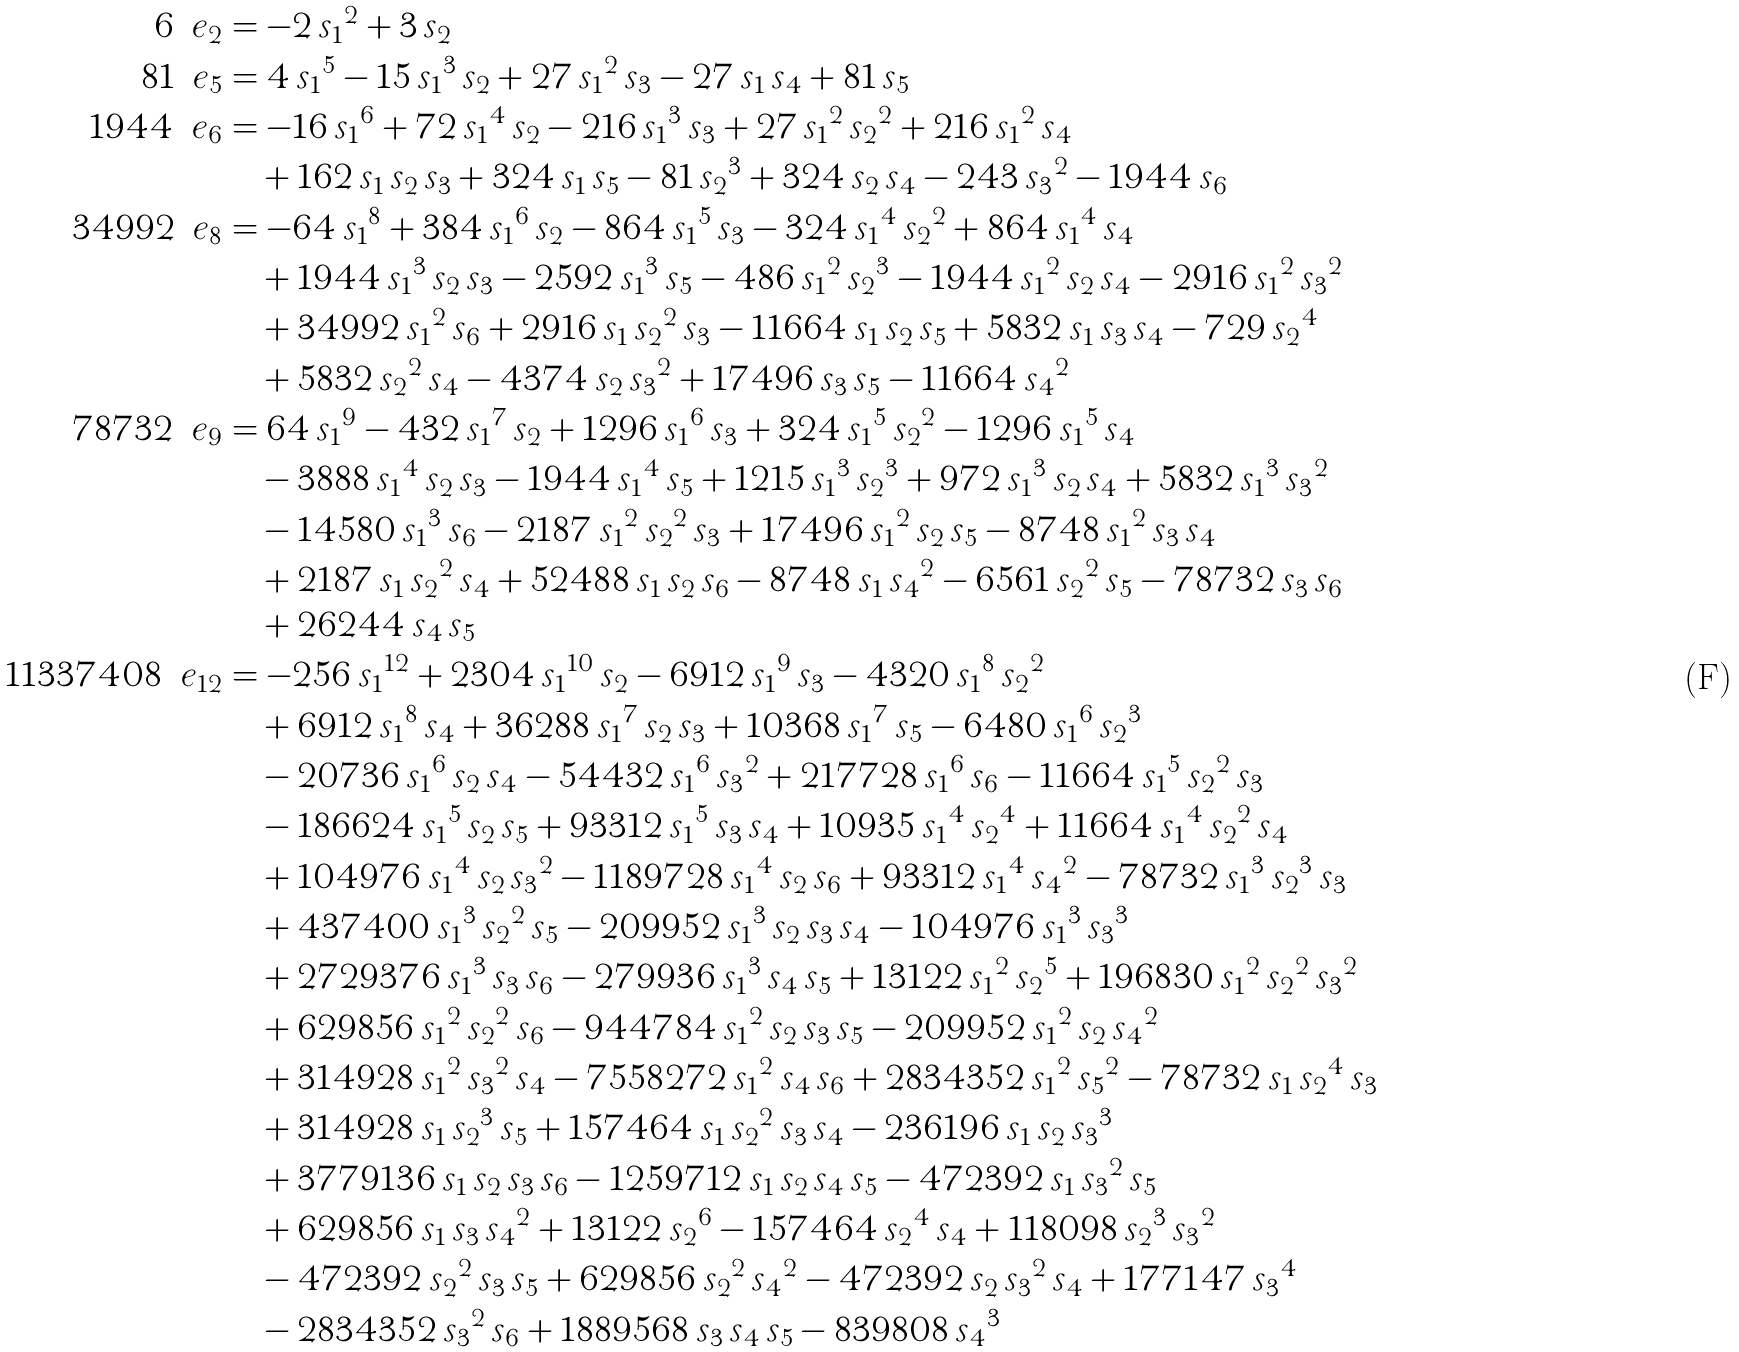Convert formula to latex. <formula><loc_0><loc_0><loc_500><loc_500>6 \, { \ e _ { 2 } } & = - 2 \, { s _ { 1 } } ^ { 2 } + 3 \, s _ { 2 } \\ 8 1 \, { \ e _ { 5 } } & = 4 \, { s _ { 1 } } ^ { 5 } - 1 5 \, { s _ { 1 } } ^ { 3 } \, s _ { 2 } + 2 7 \, { s _ { 1 } } ^ { 2 } \, s _ { 3 } - 2 7 \, s _ { 1 } \, s _ { 4 } + 8 1 \, s _ { 5 } \\ 1 9 4 4 \, { \ e _ { 6 } } & = - 1 6 \, { s _ { 1 } } ^ { 6 } + 7 2 \, { s _ { 1 } } ^ { 4 } \, s _ { 2 } - 2 1 6 \, { s _ { 1 } } ^ { 3 } \, s _ { 3 } + 2 7 \, { s _ { 1 } } ^ { 2 } \, { s _ { 2 } } ^ { 2 } + 2 1 6 \, { s _ { 1 } } ^ { 2 } \, s _ { 4 } \\ & \quad + 1 6 2 \, s _ { 1 } \, s _ { 2 } \, s _ { 3 } + 3 2 4 \, s _ { 1 } \, s _ { 5 } - 8 1 \, { s _ { 2 } } ^ { 3 } + 3 2 4 \, s _ { 2 } \, s _ { 4 } - 2 4 3 \, { s _ { 3 } } ^ { 2 } - 1 9 4 4 \, s _ { 6 } \\ 3 4 9 9 2 \, { \ e _ { 8 } } & = - 6 4 \, { s _ { 1 } } ^ { 8 } + 3 8 4 \, { s _ { 1 } } ^ { 6 } \, s _ { 2 } - 8 6 4 \, { s _ { 1 } } ^ { 5 } \, s _ { 3 } - 3 2 4 \, { s _ { 1 } } ^ { 4 } \, { s _ { 2 } } ^ { 2 } + 8 6 4 \, { s _ { 1 } } ^ { 4 } \, s _ { 4 } \\ & \quad + 1 9 4 4 \, { s _ { 1 } } ^ { 3 } \, s _ { 2 } \, s _ { 3 } - 2 5 9 2 \, { s _ { 1 } } ^ { 3 } \, s _ { 5 } - 4 8 6 \, { s _ { 1 } } ^ { 2 } \, { s _ { 2 } } ^ { 3 } - 1 9 4 4 \, { s _ { 1 } } ^ { 2 } \, s _ { 2 } \, s _ { 4 } - 2 9 1 6 \, { s _ { 1 } } ^ { 2 } \, { s _ { 3 } } ^ { 2 } \\ & \quad + 3 4 9 9 2 \, { s _ { 1 } } ^ { 2 } \, s _ { 6 } + 2 9 1 6 \, s _ { 1 } \, { s _ { 2 } } ^ { 2 } \, s _ { 3 } - 1 1 6 6 4 \, s _ { 1 } \, s _ { 2 } \, s _ { 5 } + 5 8 3 2 \, s _ { 1 } \, s _ { 3 } \, s _ { 4 } - 7 2 9 \, { s _ { 2 } } ^ { 4 } \\ & \quad + 5 8 3 2 \, { s _ { 2 } } ^ { 2 } \, s _ { 4 } - 4 3 7 4 \, s _ { 2 } \, { s _ { 3 } } ^ { 2 } + 1 7 4 9 6 \, s _ { 3 } \, s _ { 5 } - 1 1 6 6 4 \, { s _ { 4 } } ^ { 2 } \\ 7 8 7 3 2 \, { \ e _ { 9 } } & = 6 4 \, { s _ { 1 } } ^ { 9 } - 4 3 2 \, { s _ { 1 } } ^ { 7 } \, s _ { 2 } + 1 2 9 6 \, { s _ { 1 } } ^ { 6 } \, s _ { 3 } + 3 2 4 \, { s _ { 1 } } ^ { 5 } \, { s _ { 2 } } ^ { 2 } - 1 2 9 6 \, { s _ { 1 } } ^ { 5 } \, s _ { 4 } \\ & \quad - 3 8 8 8 \, { s _ { 1 } } ^ { 4 } \, s _ { 2 } \, s _ { 3 } - 1 9 4 4 \, { s _ { 1 } } ^ { 4 } \, s _ { 5 } + 1 2 1 5 \, { s _ { 1 } } ^ { 3 } \, { s _ { 2 } } ^ { 3 } + 9 7 2 \, { s _ { 1 } } ^ { 3 } \, s _ { 2 } \, s _ { 4 } + 5 8 3 2 \, { s _ { 1 } } ^ { 3 } \, { s _ { 3 } } ^ { 2 } \\ & \quad - 1 4 5 8 0 \, { s _ { 1 } } ^ { 3 } \, s _ { 6 } - 2 1 8 7 \, { s _ { 1 } } ^ { 2 } \, { s _ { 2 } } ^ { 2 } \, s _ { 3 } + 1 7 4 9 6 \, { s _ { 1 } } ^ { 2 } \, s _ { 2 } \, s _ { 5 } - 8 7 4 8 \, { s _ { 1 } } ^ { 2 } \, s _ { 3 } \, s _ { 4 } \\ & \quad + 2 1 8 7 \, s _ { 1 } \, { s _ { 2 } } ^ { 2 } \, s _ { 4 } + 5 2 4 8 8 \, s _ { 1 } \, s _ { 2 } \, s _ { 6 } - 8 7 4 8 \, s _ { 1 } \, { s _ { 4 } } ^ { 2 } - 6 5 6 1 \, { s _ { 2 } } ^ { 2 } \, s _ { 5 } - 7 8 7 3 2 \, s _ { 3 } \, s _ { 6 } \\ & \quad + 2 6 2 4 4 \, s _ { 4 } \, s _ { 5 } \\ 1 1 3 3 7 4 0 8 \, { \ e _ { 1 2 } } & = - 2 5 6 \, { s _ { 1 } } ^ { 1 2 } + 2 3 0 4 \, { s _ { 1 } } ^ { 1 0 } \, s _ { 2 } - 6 9 1 2 \, { s _ { 1 } } ^ { 9 } \, s _ { 3 } - 4 3 2 0 \, { s _ { 1 } } ^ { 8 } \, { s _ { 2 } } ^ { 2 } \\ & \quad + 6 9 1 2 \, { s _ { 1 } } ^ { 8 } \, s _ { 4 } + 3 6 2 8 8 \, { s _ { 1 } } ^ { 7 } \, s _ { 2 } \, s _ { 3 } + 1 0 3 6 8 \, { s _ { 1 } } ^ { 7 } \, s _ { 5 } - 6 4 8 0 \, { s _ { 1 } } ^ { 6 } \, { s _ { 2 } } ^ { 3 } \\ & \quad - 2 0 7 3 6 \, { s _ { 1 } } ^ { 6 } \, s _ { 2 } \, s _ { 4 } - 5 4 4 3 2 \, { s _ { 1 } } ^ { 6 } \, { s _ { 3 } } ^ { 2 } + 2 1 7 7 2 8 \, { s _ { 1 } } ^ { 6 } \, s _ { 6 } - 1 1 6 6 4 \, { s _ { 1 } } ^ { 5 } \, { s _ { 2 } } ^ { 2 } \, s _ { 3 } \\ & \quad - 1 8 6 6 2 4 \, { s _ { 1 } } ^ { 5 } \, s _ { 2 } \, s _ { 5 } + 9 3 3 1 2 \, { s _ { 1 } } ^ { 5 } \, s _ { 3 } \, s _ { 4 } + 1 0 9 3 5 \, { s _ { 1 } } ^ { 4 } \, { s _ { 2 } } ^ { 4 } + 1 1 6 6 4 \, { s _ { 1 } } ^ { 4 } \, { s _ { 2 } } ^ { 2 } \, s _ { 4 } \\ & \quad + 1 0 4 9 7 6 \, { s _ { 1 } } ^ { 4 } \, s _ { 2 } \, { s _ { 3 } } ^ { 2 } - 1 1 8 9 7 2 8 \, { s _ { 1 } } ^ { 4 } \, s _ { 2 } \, s _ { 6 } + 9 3 3 1 2 \, { s _ { 1 } } ^ { 4 } \, { s _ { 4 } } ^ { 2 } - 7 8 7 3 2 \, { s _ { 1 } } ^ { 3 } \, { s _ { 2 } } ^ { 3 } \, s _ { 3 } \\ & \quad + 4 3 7 4 0 0 \, { s _ { 1 } } ^ { 3 } \, { s _ { 2 } } ^ { 2 } \, s _ { 5 } - 2 0 9 9 5 2 \, { s _ { 1 } } ^ { 3 } \, s _ { 2 } \, s _ { 3 } \, s _ { 4 } - 1 0 4 9 7 6 \, { s _ { 1 } } ^ { 3 } \, { s _ { 3 } } ^ { 3 } \\ & \quad + 2 7 2 9 3 7 6 \, { s _ { 1 } } ^ { 3 } \, s _ { 3 } \, s _ { 6 } - 2 7 9 9 3 6 \, { s _ { 1 } } ^ { 3 } \, s _ { 4 } \, s _ { 5 } + 1 3 1 2 2 \, { s _ { 1 } } ^ { 2 } \, { s _ { 2 } } ^ { 5 } + 1 9 6 8 3 0 \, { s _ { 1 } } ^ { 2 } \, { s _ { 2 } } ^ { 2 } \, { s _ { 3 } } ^ { 2 } \\ & \quad + 6 2 9 8 5 6 \, { s _ { 1 } } ^ { 2 } \, { s _ { 2 } } ^ { 2 } \, s _ { 6 } - 9 4 4 7 8 4 \, { s _ { 1 } } ^ { 2 } \, s _ { 2 } \, s _ { 3 } \, s _ { 5 } - 2 0 9 9 5 2 \, { s _ { 1 } } ^ { 2 } \, s _ { 2 } \, { s _ { 4 } } ^ { 2 } \\ & \quad + 3 1 4 9 2 8 \, { s _ { 1 } } ^ { 2 } \, { s _ { 3 } } ^ { 2 } \, s _ { 4 } - 7 5 5 8 2 7 2 \, { s _ { 1 } } ^ { 2 } \, s _ { 4 } \, s _ { 6 } + 2 8 3 4 3 5 2 \, { s _ { 1 } } ^ { 2 } \, { s _ { 5 } } ^ { 2 } - 7 8 7 3 2 \, s _ { 1 } \, { s _ { 2 } } ^ { 4 } \, s _ { 3 } \\ & \quad + 3 1 4 9 2 8 \, s _ { 1 } \, { s _ { 2 } } ^ { 3 } \, s _ { 5 } + 1 5 7 4 6 4 \, s _ { 1 } \, { s _ { 2 } } ^ { 2 } \, s _ { 3 } \, s _ { 4 } - 2 3 6 1 9 6 \, s _ { 1 } \, s _ { 2 } \, { s _ { 3 } } ^ { 3 } \\ & \quad + 3 7 7 9 1 3 6 \, s _ { 1 } \, s _ { 2 } \, s _ { 3 } \, s _ { 6 } - 1 2 5 9 7 1 2 \, s _ { 1 } \, s _ { 2 } \, s _ { 4 } \, s _ { 5 } - 4 7 2 3 9 2 \, s _ { 1 } \, { s _ { 3 } } ^ { 2 } \, s _ { 5 } \\ & \quad + 6 2 9 8 5 6 \, s _ { 1 } \, s _ { 3 } \, { s _ { 4 } } ^ { 2 } + 1 3 1 2 2 \, { s _ { 2 } } ^ { 6 } - 1 5 7 4 6 4 \, { s _ { 2 } } ^ { 4 } \, s _ { 4 } + 1 1 8 0 9 8 \, { s _ { 2 } } ^ { 3 } \, { s _ { 3 } } ^ { 2 } \\ & \quad - 4 7 2 3 9 2 \, { s _ { 2 } } ^ { 2 } \, s _ { 3 } \, s _ { 5 } + 6 2 9 8 5 6 \, { s _ { 2 } } ^ { 2 } \, { s _ { 4 } } ^ { 2 } - 4 7 2 3 9 2 \, s _ { 2 } \, { s _ { 3 } } ^ { 2 } \, s _ { 4 } + 1 7 7 1 4 7 \, { s _ { 3 } } ^ { 4 } \\ & \quad - 2 8 3 4 3 5 2 \, { s _ { 3 } } ^ { 2 } \, s _ { 6 } + 1 8 8 9 5 6 8 \, s _ { 3 } \, s _ { 4 } \, s _ { 5 } - 8 3 9 8 0 8 \, { s _ { 4 } } ^ { 3 }</formula> 